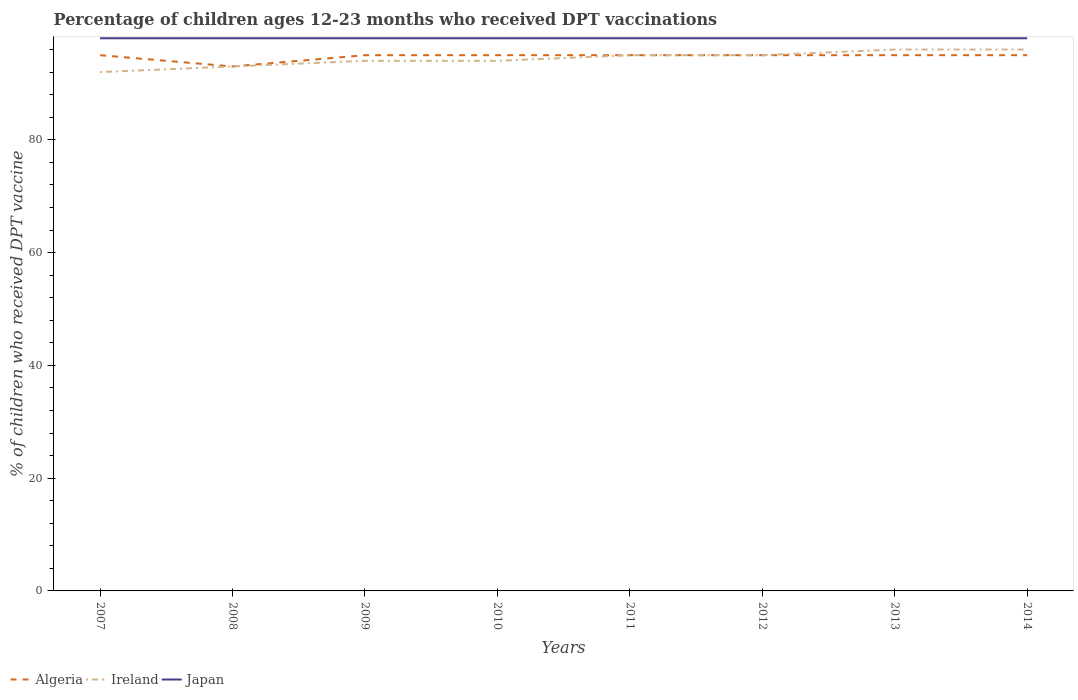How many different coloured lines are there?
Your answer should be very brief. 3. Does the line corresponding to Japan intersect with the line corresponding to Algeria?
Ensure brevity in your answer.  No. Is the number of lines equal to the number of legend labels?
Ensure brevity in your answer.  Yes. Across all years, what is the maximum percentage of children who received DPT vaccination in Algeria?
Your answer should be compact. 93. In which year was the percentage of children who received DPT vaccination in Japan maximum?
Keep it short and to the point. 2007. What is the difference between the highest and the second highest percentage of children who received DPT vaccination in Japan?
Give a very brief answer. 0. What is the difference between the highest and the lowest percentage of children who received DPT vaccination in Japan?
Offer a terse response. 0. How many lines are there?
Ensure brevity in your answer.  3. Are the values on the major ticks of Y-axis written in scientific E-notation?
Offer a very short reply. No. Does the graph contain grids?
Ensure brevity in your answer.  No. How many legend labels are there?
Ensure brevity in your answer.  3. How are the legend labels stacked?
Offer a very short reply. Horizontal. What is the title of the graph?
Provide a short and direct response. Percentage of children ages 12-23 months who received DPT vaccinations. Does "Tonga" appear as one of the legend labels in the graph?
Give a very brief answer. No. What is the label or title of the Y-axis?
Offer a very short reply. % of children who received DPT vaccine. What is the % of children who received DPT vaccine of Algeria in 2007?
Your answer should be compact. 95. What is the % of children who received DPT vaccine in Ireland in 2007?
Offer a terse response. 92. What is the % of children who received DPT vaccine in Algeria in 2008?
Your response must be concise. 93. What is the % of children who received DPT vaccine in Ireland in 2008?
Provide a short and direct response. 93. What is the % of children who received DPT vaccine in Japan in 2008?
Your response must be concise. 98. What is the % of children who received DPT vaccine of Ireland in 2009?
Ensure brevity in your answer.  94. What is the % of children who received DPT vaccine in Japan in 2009?
Give a very brief answer. 98. What is the % of children who received DPT vaccine of Algeria in 2010?
Offer a terse response. 95. What is the % of children who received DPT vaccine in Ireland in 2010?
Provide a short and direct response. 94. What is the % of children who received DPT vaccine in Japan in 2010?
Provide a succinct answer. 98. What is the % of children who received DPT vaccine in Algeria in 2011?
Make the answer very short. 95. What is the % of children who received DPT vaccine of Ireland in 2011?
Provide a succinct answer. 95. What is the % of children who received DPT vaccine in Algeria in 2012?
Offer a terse response. 95. What is the % of children who received DPT vaccine in Ireland in 2012?
Ensure brevity in your answer.  95. What is the % of children who received DPT vaccine of Japan in 2012?
Provide a short and direct response. 98. What is the % of children who received DPT vaccine of Ireland in 2013?
Provide a succinct answer. 96. What is the % of children who received DPT vaccine of Ireland in 2014?
Keep it short and to the point. 96. Across all years, what is the maximum % of children who received DPT vaccine of Algeria?
Provide a succinct answer. 95. Across all years, what is the maximum % of children who received DPT vaccine of Ireland?
Make the answer very short. 96. Across all years, what is the minimum % of children who received DPT vaccine in Algeria?
Offer a very short reply. 93. Across all years, what is the minimum % of children who received DPT vaccine of Ireland?
Offer a very short reply. 92. What is the total % of children who received DPT vaccine of Algeria in the graph?
Provide a succinct answer. 758. What is the total % of children who received DPT vaccine in Ireland in the graph?
Your answer should be compact. 755. What is the total % of children who received DPT vaccine of Japan in the graph?
Keep it short and to the point. 784. What is the difference between the % of children who received DPT vaccine in Algeria in 2007 and that in 2008?
Ensure brevity in your answer.  2. What is the difference between the % of children who received DPT vaccine in Ireland in 2007 and that in 2008?
Ensure brevity in your answer.  -1. What is the difference between the % of children who received DPT vaccine of Japan in 2007 and that in 2008?
Your answer should be compact. 0. What is the difference between the % of children who received DPT vaccine of Ireland in 2007 and that in 2009?
Offer a terse response. -2. What is the difference between the % of children who received DPT vaccine of Japan in 2007 and that in 2009?
Provide a short and direct response. 0. What is the difference between the % of children who received DPT vaccine in Japan in 2007 and that in 2010?
Your response must be concise. 0. What is the difference between the % of children who received DPT vaccine in Ireland in 2007 and that in 2012?
Give a very brief answer. -3. What is the difference between the % of children who received DPT vaccine of Algeria in 2007 and that in 2013?
Your response must be concise. 0. What is the difference between the % of children who received DPT vaccine of Japan in 2007 and that in 2013?
Your answer should be very brief. 0. What is the difference between the % of children who received DPT vaccine of Japan in 2007 and that in 2014?
Keep it short and to the point. 0. What is the difference between the % of children who received DPT vaccine in Algeria in 2008 and that in 2009?
Provide a succinct answer. -2. What is the difference between the % of children who received DPT vaccine in Japan in 2008 and that in 2009?
Offer a terse response. 0. What is the difference between the % of children who received DPT vaccine in Algeria in 2008 and that in 2011?
Keep it short and to the point. -2. What is the difference between the % of children who received DPT vaccine in Algeria in 2008 and that in 2012?
Your answer should be compact. -2. What is the difference between the % of children who received DPT vaccine in Ireland in 2008 and that in 2012?
Ensure brevity in your answer.  -2. What is the difference between the % of children who received DPT vaccine in Japan in 2008 and that in 2012?
Your answer should be very brief. 0. What is the difference between the % of children who received DPT vaccine in Japan in 2008 and that in 2013?
Provide a short and direct response. 0. What is the difference between the % of children who received DPT vaccine in Ireland in 2008 and that in 2014?
Give a very brief answer. -3. What is the difference between the % of children who received DPT vaccine of Ireland in 2009 and that in 2010?
Provide a short and direct response. 0. What is the difference between the % of children who received DPT vaccine in Ireland in 2009 and that in 2011?
Your answer should be compact. -1. What is the difference between the % of children who received DPT vaccine in Ireland in 2009 and that in 2013?
Offer a terse response. -2. What is the difference between the % of children who received DPT vaccine in Ireland in 2009 and that in 2014?
Your answer should be very brief. -2. What is the difference between the % of children who received DPT vaccine in Ireland in 2010 and that in 2012?
Provide a succinct answer. -1. What is the difference between the % of children who received DPT vaccine in Japan in 2010 and that in 2012?
Offer a very short reply. 0. What is the difference between the % of children who received DPT vaccine of Ireland in 2010 and that in 2013?
Offer a terse response. -2. What is the difference between the % of children who received DPT vaccine of Japan in 2010 and that in 2013?
Ensure brevity in your answer.  0. What is the difference between the % of children who received DPT vaccine of Ireland in 2010 and that in 2014?
Keep it short and to the point. -2. What is the difference between the % of children who received DPT vaccine of Japan in 2010 and that in 2014?
Offer a very short reply. 0. What is the difference between the % of children who received DPT vaccine in Algeria in 2011 and that in 2012?
Offer a terse response. 0. What is the difference between the % of children who received DPT vaccine in Ireland in 2011 and that in 2012?
Your answer should be compact. 0. What is the difference between the % of children who received DPT vaccine of Japan in 2011 and that in 2012?
Your answer should be very brief. 0. What is the difference between the % of children who received DPT vaccine in Ireland in 2011 and that in 2014?
Ensure brevity in your answer.  -1. What is the difference between the % of children who received DPT vaccine in Japan in 2011 and that in 2014?
Offer a very short reply. 0. What is the difference between the % of children who received DPT vaccine in Japan in 2012 and that in 2013?
Give a very brief answer. 0. What is the difference between the % of children who received DPT vaccine of Japan in 2012 and that in 2014?
Keep it short and to the point. 0. What is the difference between the % of children who received DPT vaccine of Algeria in 2013 and that in 2014?
Your answer should be very brief. 0. What is the difference between the % of children who received DPT vaccine of Japan in 2013 and that in 2014?
Provide a succinct answer. 0. What is the difference between the % of children who received DPT vaccine in Algeria in 2007 and the % of children who received DPT vaccine in Ireland in 2008?
Your answer should be very brief. 2. What is the difference between the % of children who received DPT vaccine in Algeria in 2007 and the % of children who received DPT vaccine in Japan in 2008?
Your answer should be compact. -3. What is the difference between the % of children who received DPT vaccine in Ireland in 2007 and the % of children who received DPT vaccine in Japan in 2008?
Keep it short and to the point. -6. What is the difference between the % of children who received DPT vaccine in Algeria in 2007 and the % of children who received DPT vaccine in Ireland in 2009?
Provide a succinct answer. 1. What is the difference between the % of children who received DPT vaccine of Ireland in 2007 and the % of children who received DPT vaccine of Japan in 2009?
Offer a very short reply. -6. What is the difference between the % of children who received DPT vaccine of Algeria in 2007 and the % of children who received DPT vaccine of Ireland in 2010?
Give a very brief answer. 1. What is the difference between the % of children who received DPT vaccine of Ireland in 2007 and the % of children who received DPT vaccine of Japan in 2011?
Make the answer very short. -6. What is the difference between the % of children who received DPT vaccine in Algeria in 2007 and the % of children who received DPT vaccine in Ireland in 2012?
Ensure brevity in your answer.  0. What is the difference between the % of children who received DPT vaccine of Algeria in 2007 and the % of children who received DPT vaccine of Japan in 2012?
Ensure brevity in your answer.  -3. What is the difference between the % of children who received DPT vaccine of Algeria in 2007 and the % of children who received DPT vaccine of Japan in 2013?
Keep it short and to the point. -3. What is the difference between the % of children who received DPT vaccine of Ireland in 2007 and the % of children who received DPT vaccine of Japan in 2014?
Provide a succinct answer. -6. What is the difference between the % of children who received DPT vaccine of Algeria in 2008 and the % of children who received DPT vaccine of Ireland in 2009?
Your response must be concise. -1. What is the difference between the % of children who received DPT vaccine of Algeria in 2008 and the % of children who received DPT vaccine of Japan in 2009?
Your answer should be very brief. -5. What is the difference between the % of children who received DPT vaccine of Algeria in 2008 and the % of children who received DPT vaccine of Japan in 2010?
Keep it short and to the point. -5. What is the difference between the % of children who received DPT vaccine in Ireland in 2008 and the % of children who received DPT vaccine in Japan in 2010?
Provide a succinct answer. -5. What is the difference between the % of children who received DPT vaccine in Algeria in 2008 and the % of children who received DPT vaccine in Ireland in 2011?
Offer a very short reply. -2. What is the difference between the % of children who received DPT vaccine of Algeria in 2008 and the % of children who received DPT vaccine of Japan in 2011?
Your response must be concise. -5. What is the difference between the % of children who received DPT vaccine in Ireland in 2008 and the % of children who received DPT vaccine in Japan in 2011?
Your answer should be very brief. -5. What is the difference between the % of children who received DPT vaccine of Algeria in 2008 and the % of children who received DPT vaccine of Japan in 2012?
Your answer should be compact. -5. What is the difference between the % of children who received DPT vaccine in Ireland in 2008 and the % of children who received DPT vaccine in Japan in 2012?
Offer a terse response. -5. What is the difference between the % of children who received DPT vaccine of Algeria in 2008 and the % of children who received DPT vaccine of Ireland in 2013?
Offer a terse response. -3. What is the difference between the % of children who received DPT vaccine in Algeria in 2008 and the % of children who received DPT vaccine in Ireland in 2014?
Provide a short and direct response. -3. What is the difference between the % of children who received DPT vaccine in Algeria in 2008 and the % of children who received DPT vaccine in Japan in 2014?
Provide a succinct answer. -5. What is the difference between the % of children who received DPT vaccine of Ireland in 2008 and the % of children who received DPT vaccine of Japan in 2014?
Offer a terse response. -5. What is the difference between the % of children who received DPT vaccine in Algeria in 2009 and the % of children who received DPT vaccine in Japan in 2010?
Provide a succinct answer. -3. What is the difference between the % of children who received DPT vaccine in Algeria in 2009 and the % of children who received DPT vaccine in Ireland in 2011?
Your answer should be compact. 0. What is the difference between the % of children who received DPT vaccine of Algeria in 2009 and the % of children who received DPT vaccine of Ireland in 2012?
Keep it short and to the point. 0. What is the difference between the % of children who received DPT vaccine in Algeria in 2009 and the % of children who received DPT vaccine in Japan in 2012?
Your answer should be very brief. -3. What is the difference between the % of children who received DPT vaccine in Ireland in 2009 and the % of children who received DPT vaccine in Japan in 2012?
Your response must be concise. -4. What is the difference between the % of children who received DPT vaccine of Algeria in 2009 and the % of children who received DPT vaccine of Ireland in 2013?
Your answer should be compact. -1. What is the difference between the % of children who received DPT vaccine of Ireland in 2009 and the % of children who received DPT vaccine of Japan in 2013?
Ensure brevity in your answer.  -4. What is the difference between the % of children who received DPT vaccine of Ireland in 2009 and the % of children who received DPT vaccine of Japan in 2014?
Offer a very short reply. -4. What is the difference between the % of children who received DPT vaccine in Algeria in 2010 and the % of children who received DPT vaccine in Japan in 2011?
Your answer should be very brief. -3. What is the difference between the % of children who received DPT vaccine in Ireland in 2010 and the % of children who received DPT vaccine in Japan in 2011?
Your response must be concise. -4. What is the difference between the % of children who received DPT vaccine in Algeria in 2010 and the % of children who received DPT vaccine in Ireland in 2012?
Make the answer very short. 0. What is the difference between the % of children who received DPT vaccine of Algeria in 2010 and the % of children who received DPT vaccine of Ireland in 2013?
Provide a succinct answer. -1. What is the difference between the % of children who received DPT vaccine of Ireland in 2010 and the % of children who received DPT vaccine of Japan in 2013?
Provide a succinct answer. -4. What is the difference between the % of children who received DPT vaccine of Algeria in 2010 and the % of children who received DPT vaccine of Japan in 2014?
Your answer should be very brief. -3. What is the difference between the % of children who received DPT vaccine in Ireland in 2010 and the % of children who received DPT vaccine in Japan in 2014?
Make the answer very short. -4. What is the difference between the % of children who received DPT vaccine of Algeria in 2011 and the % of children who received DPT vaccine of Ireland in 2012?
Give a very brief answer. 0. What is the difference between the % of children who received DPT vaccine of Algeria in 2011 and the % of children who received DPT vaccine of Japan in 2012?
Ensure brevity in your answer.  -3. What is the difference between the % of children who received DPT vaccine in Ireland in 2011 and the % of children who received DPT vaccine in Japan in 2012?
Your answer should be very brief. -3. What is the difference between the % of children who received DPT vaccine in Ireland in 2011 and the % of children who received DPT vaccine in Japan in 2013?
Provide a short and direct response. -3. What is the difference between the % of children who received DPT vaccine of Ireland in 2011 and the % of children who received DPT vaccine of Japan in 2014?
Give a very brief answer. -3. What is the difference between the % of children who received DPT vaccine in Algeria in 2012 and the % of children who received DPT vaccine in Ireland in 2013?
Give a very brief answer. -1. What is the difference between the % of children who received DPT vaccine in Algeria in 2012 and the % of children who received DPT vaccine in Japan in 2013?
Keep it short and to the point. -3. What is the difference between the % of children who received DPT vaccine in Ireland in 2012 and the % of children who received DPT vaccine in Japan in 2013?
Ensure brevity in your answer.  -3. What is the difference between the % of children who received DPT vaccine of Algeria in 2013 and the % of children who received DPT vaccine of Ireland in 2014?
Offer a very short reply. -1. What is the difference between the % of children who received DPT vaccine of Algeria in 2013 and the % of children who received DPT vaccine of Japan in 2014?
Make the answer very short. -3. What is the difference between the % of children who received DPT vaccine of Ireland in 2013 and the % of children who received DPT vaccine of Japan in 2014?
Keep it short and to the point. -2. What is the average % of children who received DPT vaccine in Algeria per year?
Make the answer very short. 94.75. What is the average % of children who received DPT vaccine of Ireland per year?
Offer a very short reply. 94.38. What is the average % of children who received DPT vaccine of Japan per year?
Ensure brevity in your answer.  98. In the year 2007, what is the difference between the % of children who received DPT vaccine of Algeria and % of children who received DPT vaccine of Ireland?
Keep it short and to the point. 3. In the year 2008, what is the difference between the % of children who received DPT vaccine in Algeria and % of children who received DPT vaccine in Ireland?
Offer a terse response. 0. In the year 2008, what is the difference between the % of children who received DPT vaccine of Algeria and % of children who received DPT vaccine of Japan?
Offer a terse response. -5. In the year 2009, what is the difference between the % of children who received DPT vaccine of Ireland and % of children who received DPT vaccine of Japan?
Ensure brevity in your answer.  -4. In the year 2011, what is the difference between the % of children who received DPT vaccine in Ireland and % of children who received DPT vaccine in Japan?
Give a very brief answer. -3. In the year 2012, what is the difference between the % of children who received DPT vaccine in Algeria and % of children who received DPT vaccine in Ireland?
Ensure brevity in your answer.  0. In the year 2012, what is the difference between the % of children who received DPT vaccine in Ireland and % of children who received DPT vaccine in Japan?
Make the answer very short. -3. In the year 2013, what is the difference between the % of children who received DPT vaccine of Ireland and % of children who received DPT vaccine of Japan?
Provide a succinct answer. -2. In the year 2014, what is the difference between the % of children who received DPT vaccine of Algeria and % of children who received DPT vaccine of Japan?
Your answer should be compact. -3. What is the ratio of the % of children who received DPT vaccine of Algeria in 2007 to that in 2008?
Provide a succinct answer. 1.02. What is the ratio of the % of children who received DPT vaccine of Ireland in 2007 to that in 2008?
Your response must be concise. 0.99. What is the ratio of the % of children who received DPT vaccine in Ireland in 2007 to that in 2009?
Ensure brevity in your answer.  0.98. What is the ratio of the % of children who received DPT vaccine in Japan in 2007 to that in 2009?
Provide a short and direct response. 1. What is the ratio of the % of children who received DPT vaccine of Ireland in 2007 to that in 2010?
Make the answer very short. 0.98. What is the ratio of the % of children who received DPT vaccine of Japan in 2007 to that in 2010?
Give a very brief answer. 1. What is the ratio of the % of children who received DPT vaccine in Ireland in 2007 to that in 2011?
Ensure brevity in your answer.  0.97. What is the ratio of the % of children who received DPT vaccine in Algeria in 2007 to that in 2012?
Ensure brevity in your answer.  1. What is the ratio of the % of children who received DPT vaccine in Ireland in 2007 to that in 2012?
Give a very brief answer. 0.97. What is the ratio of the % of children who received DPT vaccine of Japan in 2007 to that in 2013?
Ensure brevity in your answer.  1. What is the ratio of the % of children who received DPT vaccine of Ireland in 2007 to that in 2014?
Your response must be concise. 0.96. What is the ratio of the % of children who received DPT vaccine of Japan in 2007 to that in 2014?
Make the answer very short. 1. What is the ratio of the % of children who received DPT vaccine in Algeria in 2008 to that in 2009?
Offer a terse response. 0.98. What is the ratio of the % of children who received DPT vaccine of Japan in 2008 to that in 2009?
Give a very brief answer. 1. What is the ratio of the % of children who received DPT vaccine of Algeria in 2008 to that in 2010?
Offer a terse response. 0.98. What is the ratio of the % of children who received DPT vaccine in Japan in 2008 to that in 2010?
Offer a terse response. 1. What is the ratio of the % of children who received DPT vaccine of Algeria in 2008 to that in 2011?
Your answer should be very brief. 0.98. What is the ratio of the % of children who received DPT vaccine of Ireland in 2008 to that in 2011?
Offer a very short reply. 0.98. What is the ratio of the % of children who received DPT vaccine in Algeria in 2008 to that in 2012?
Ensure brevity in your answer.  0.98. What is the ratio of the % of children who received DPT vaccine of Ireland in 2008 to that in 2012?
Provide a short and direct response. 0.98. What is the ratio of the % of children who received DPT vaccine of Japan in 2008 to that in 2012?
Provide a succinct answer. 1. What is the ratio of the % of children who received DPT vaccine of Algeria in 2008 to that in 2013?
Provide a short and direct response. 0.98. What is the ratio of the % of children who received DPT vaccine in Ireland in 2008 to that in 2013?
Your response must be concise. 0.97. What is the ratio of the % of children who received DPT vaccine in Japan in 2008 to that in 2013?
Provide a succinct answer. 1. What is the ratio of the % of children who received DPT vaccine of Algeria in 2008 to that in 2014?
Your answer should be very brief. 0.98. What is the ratio of the % of children who received DPT vaccine in Ireland in 2008 to that in 2014?
Offer a terse response. 0.97. What is the ratio of the % of children who received DPT vaccine of Ireland in 2009 to that in 2010?
Make the answer very short. 1. What is the ratio of the % of children who received DPT vaccine in Japan in 2009 to that in 2010?
Provide a short and direct response. 1. What is the ratio of the % of children who received DPT vaccine in Ireland in 2009 to that in 2012?
Provide a succinct answer. 0.99. What is the ratio of the % of children who received DPT vaccine in Japan in 2009 to that in 2012?
Provide a short and direct response. 1. What is the ratio of the % of children who received DPT vaccine of Algeria in 2009 to that in 2013?
Your response must be concise. 1. What is the ratio of the % of children who received DPT vaccine in Ireland in 2009 to that in 2013?
Offer a very short reply. 0.98. What is the ratio of the % of children who received DPT vaccine in Japan in 2009 to that in 2013?
Make the answer very short. 1. What is the ratio of the % of children who received DPT vaccine of Algeria in 2009 to that in 2014?
Offer a very short reply. 1. What is the ratio of the % of children who received DPT vaccine of Ireland in 2009 to that in 2014?
Provide a short and direct response. 0.98. What is the ratio of the % of children who received DPT vaccine of Japan in 2009 to that in 2014?
Offer a very short reply. 1. What is the ratio of the % of children who received DPT vaccine of Algeria in 2010 to that in 2011?
Provide a short and direct response. 1. What is the ratio of the % of children who received DPT vaccine of Ireland in 2010 to that in 2011?
Provide a short and direct response. 0.99. What is the ratio of the % of children who received DPT vaccine of Ireland in 2010 to that in 2013?
Your response must be concise. 0.98. What is the ratio of the % of children who received DPT vaccine of Algeria in 2010 to that in 2014?
Offer a terse response. 1. What is the ratio of the % of children who received DPT vaccine of Ireland in 2010 to that in 2014?
Make the answer very short. 0.98. What is the ratio of the % of children who received DPT vaccine in Japan in 2010 to that in 2014?
Provide a succinct answer. 1. What is the ratio of the % of children who received DPT vaccine of Algeria in 2011 to that in 2012?
Provide a succinct answer. 1. What is the ratio of the % of children who received DPT vaccine of Algeria in 2011 to that in 2013?
Make the answer very short. 1. What is the ratio of the % of children who received DPT vaccine in Algeria in 2011 to that in 2014?
Offer a terse response. 1. What is the ratio of the % of children who received DPT vaccine in Japan in 2011 to that in 2014?
Offer a very short reply. 1. What is the ratio of the % of children who received DPT vaccine of Algeria in 2012 to that in 2013?
Your response must be concise. 1. What is the ratio of the % of children who received DPT vaccine of Ireland in 2012 to that in 2013?
Offer a very short reply. 0.99. What is the ratio of the % of children who received DPT vaccine in Japan in 2012 to that in 2013?
Offer a very short reply. 1. What is the ratio of the % of children who received DPT vaccine of Algeria in 2012 to that in 2014?
Your answer should be very brief. 1. What is the ratio of the % of children who received DPT vaccine of Japan in 2012 to that in 2014?
Give a very brief answer. 1. What is the ratio of the % of children who received DPT vaccine in Ireland in 2013 to that in 2014?
Your answer should be compact. 1. What is the difference between the highest and the second highest % of children who received DPT vaccine of Japan?
Your answer should be compact. 0. What is the difference between the highest and the lowest % of children who received DPT vaccine of Japan?
Your response must be concise. 0. 